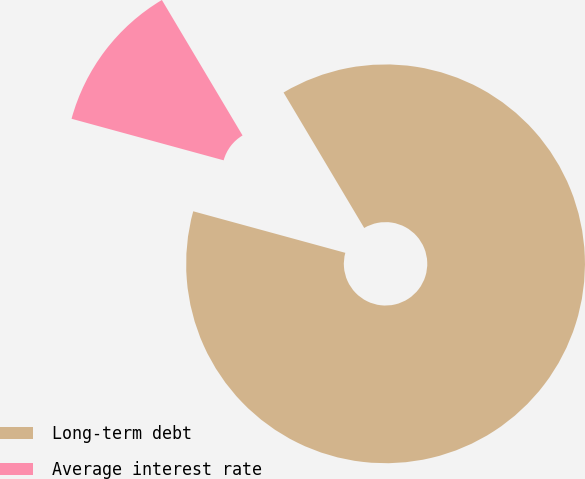Convert chart to OTSL. <chart><loc_0><loc_0><loc_500><loc_500><pie_chart><fcel>Long-term debt<fcel>Average interest rate<nl><fcel>87.79%<fcel>12.21%<nl></chart> 